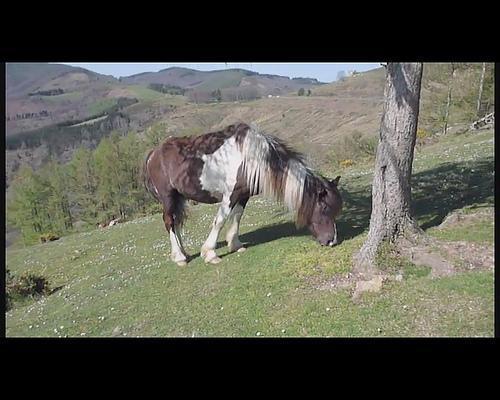How many horses are there?
Give a very brief answer. 1. 